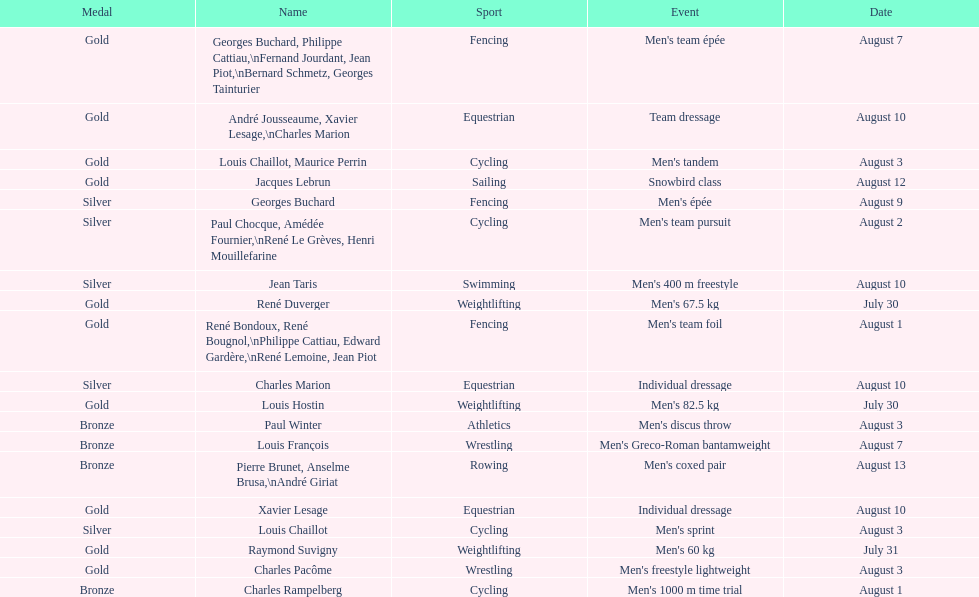How many gold medals did this country win during these olympics? 10. 